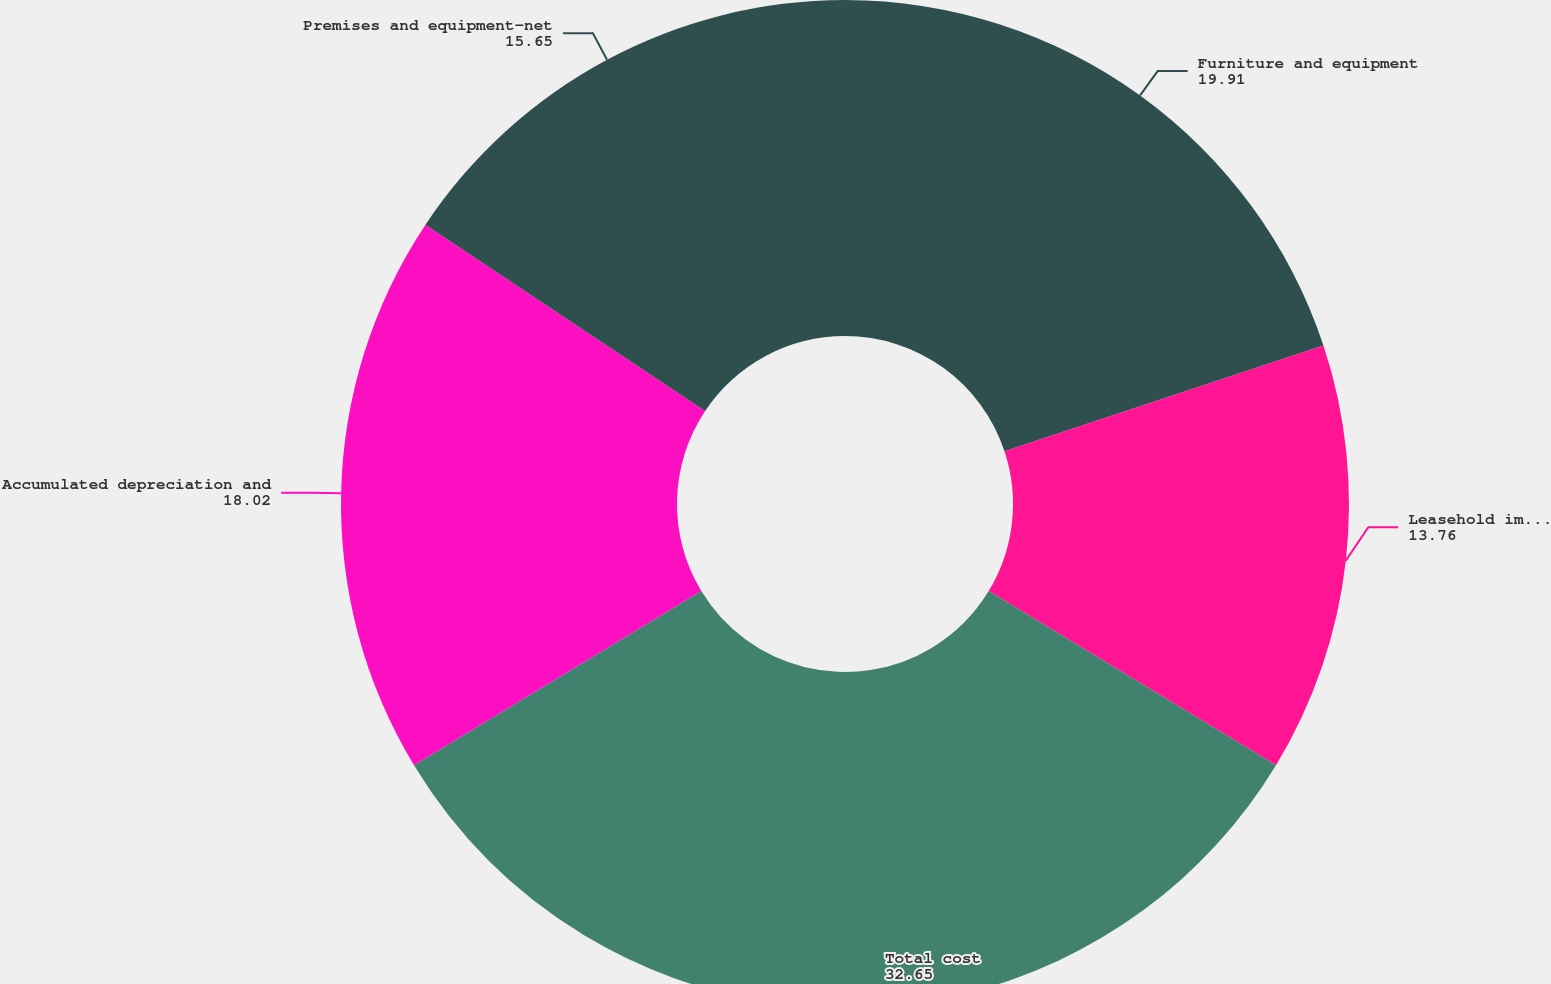Convert chart to OTSL. <chart><loc_0><loc_0><loc_500><loc_500><pie_chart><fcel>Furniture and equipment<fcel>Leasehold improvements<fcel>Total cost<fcel>Accumulated depreciation and<fcel>Premises and equipment-net<nl><fcel>19.91%<fcel>13.76%<fcel>32.65%<fcel>18.02%<fcel>15.65%<nl></chart> 